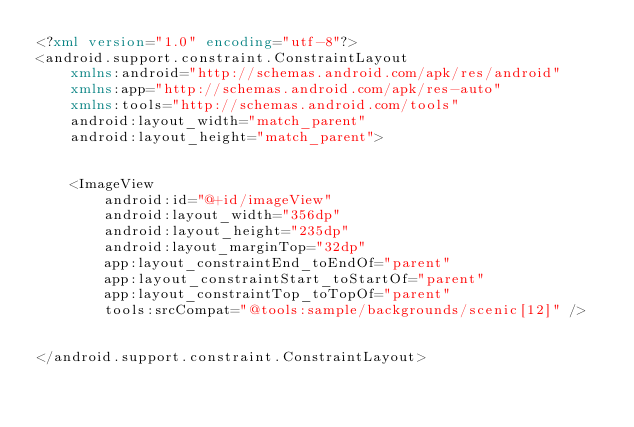Convert code to text. <code><loc_0><loc_0><loc_500><loc_500><_XML_><?xml version="1.0" encoding="utf-8"?>
<android.support.constraint.ConstraintLayout
    xmlns:android="http://schemas.android.com/apk/res/android"
    xmlns:app="http://schemas.android.com/apk/res-auto"
    xmlns:tools="http://schemas.android.com/tools"
    android:layout_width="match_parent"
    android:layout_height="match_parent">


    <ImageView
        android:id="@+id/imageView"
        android:layout_width="356dp"
        android:layout_height="235dp"
        android:layout_marginTop="32dp"
        app:layout_constraintEnd_toEndOf="parent"
        app:layout_constraintStart_toStartOf="parent"
        app:layout_constraintTop_toTopOf="parent"
        tools:srcCompat="@tools:sample/backgrounds/scenic[12]" />


</android.support.constraint.ConstraintLayout></code> 